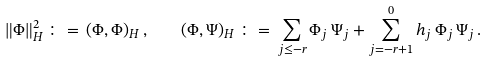<formula> <loc_0><loc_0><loc_500><loc_500>\| \Phi \| _ { H } ^ { 2 } \, \colon = \, ( \Phi , \Phi ) _ { H } \, , \quad ( \Phi , \Psi ) _ { H } \, \colon = \, \sum _ { j \leq - r } \Phi _ { j } \, \Psi _ { j } + \sum _ { j = - r + 1 } ^ { 0 } h _ { j } \, \Phi _ { j } \, \Psi _ { j } \, .</formula> 